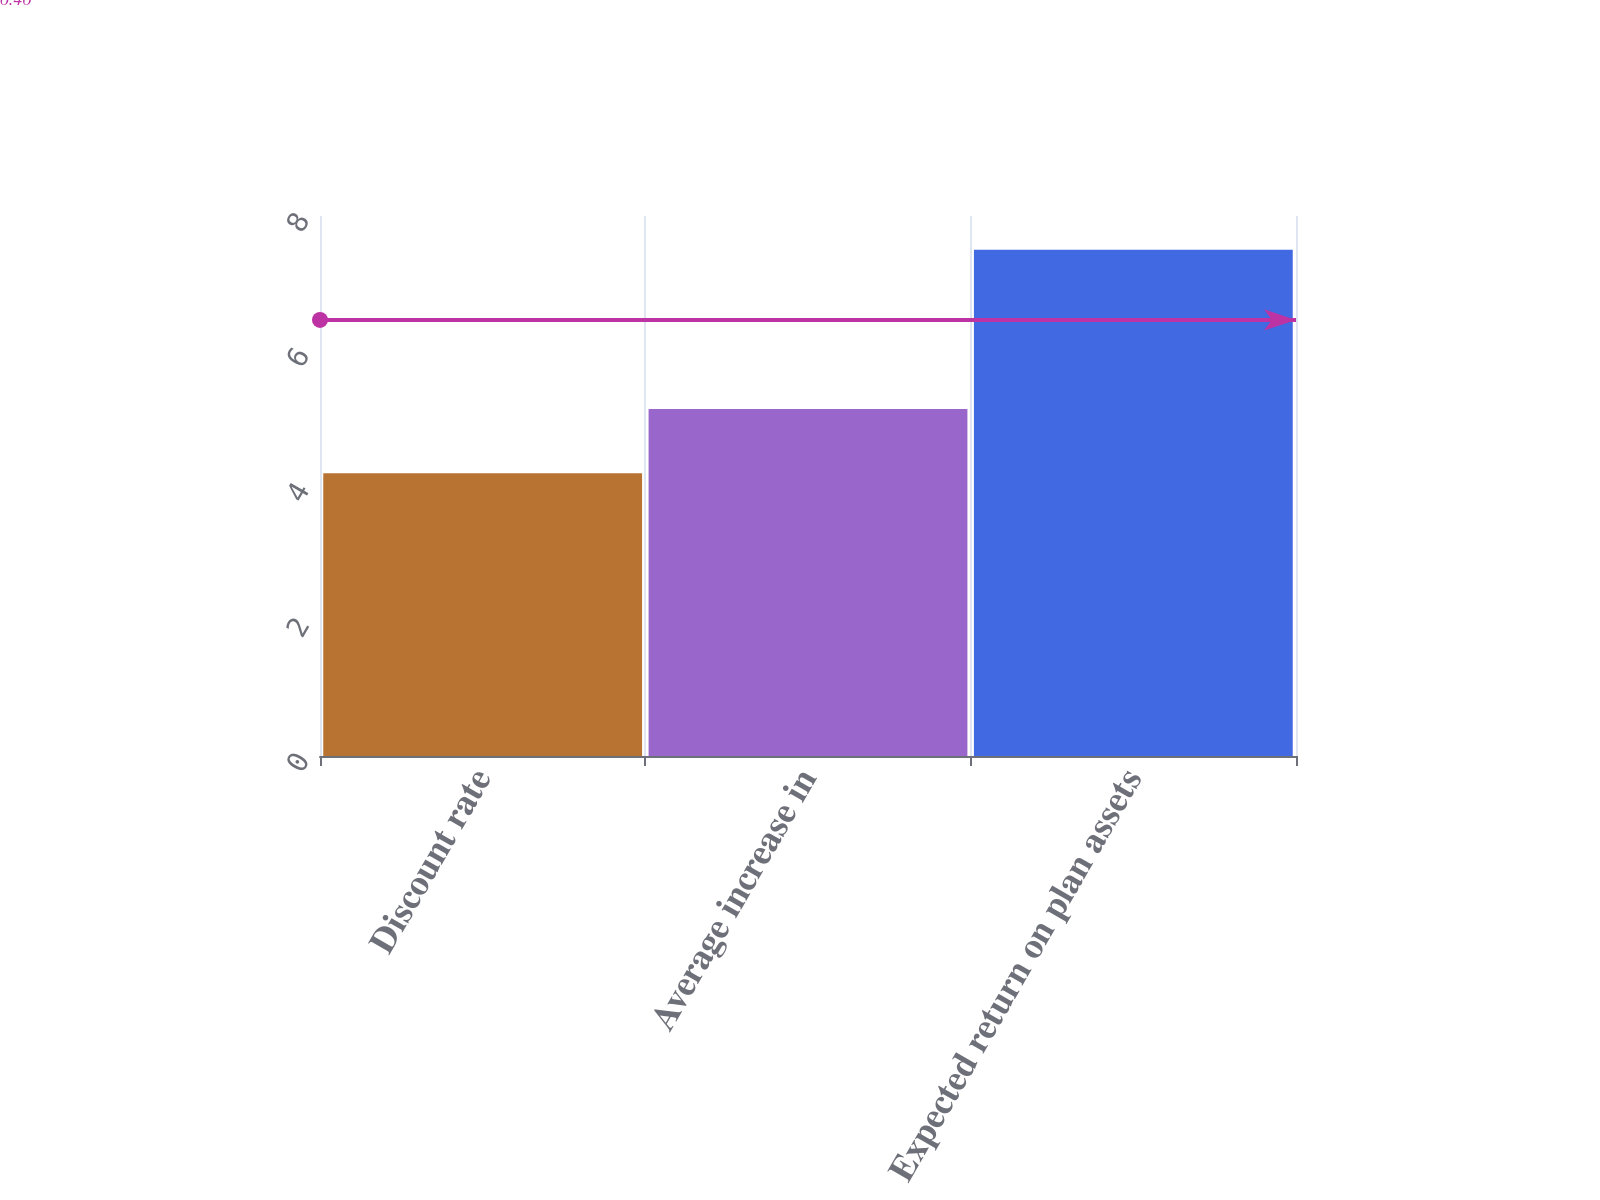Convert chart. <chart><loc_0><loc_0><loc_500><loc_500><bar_chart><fcel>Discount rate<fcel>Average increase in<fcel>Expected return on plan assets<nl><fcel>4.19<fcel>5.14<fcel>7.5<nl></chart> 